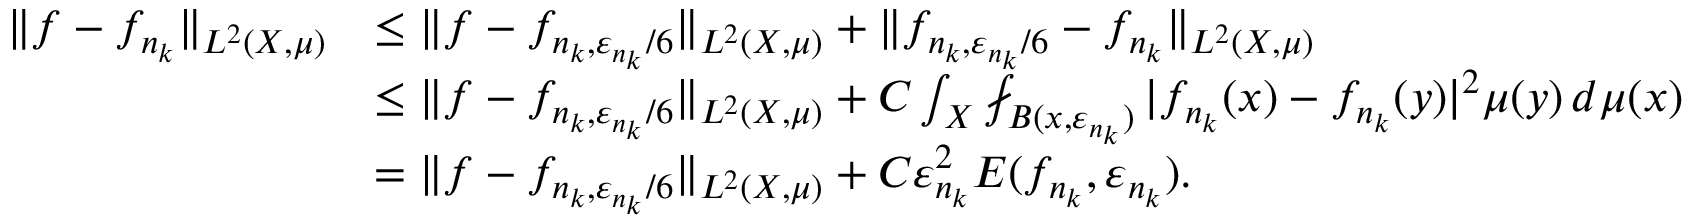Convert formula to latex. <formula><loc_0><loc_0><loc_500><loc_500>\begin{array} { r l } { \| f - f _ { n _ { k } } \| _ { L ^ { 2 } ( X , \mu ) } } & { \leq \| f - f _ { n _ { k } , \varepsilon _ { n _ { k } } { / 6 } } \| _ { L ^ { 2 } ( X , \mu ) } + \| f _ { n _ { k } , \varepsilon _ { n _ { k } } / 6 } - f _ { n _ { k } } \| _ { L ^ { 2 } ( X , \mu ) } } \\ & { \leq \| f - f _ { n _ { k } , \varepsilon _ { n _ { k } } / 6 } \| _ { L ^ { 2 } ( X , \mu ) } + C \int _ { X } \ f i n t _ { B ( x , \varepsilon _ { n _ { k } } ) } | f _ { n _ { k } } ( x ) - f _ { n _ { k } } ( y ) | ^ { 2 } \mu ( y ) \, d \mu ( x ) } \\ & { = \| f - f _ { n _ { k } , \varepsilon _ { n _ { k } } { / 6 } } \| _ { L ^ { 2 } ( X , \mu ) } + C \varepsilon _ { n _ { k } } ^ { 2 } E ( f _ { n _ { k } } , \varepsilon _ { n _ { k } } ) . } \end{array}</formula> 